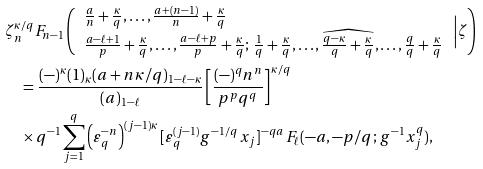<formula> <loc_0><loc_0><loc_500><loc_500>& \zeta ^ { \kappa / q } _ { n } F _ { n - 1 } \left ( \begin{array} { l } \frac { a } n + \frac { \kappa } q , \dots , \frac { a + ( n - 1 ) } n + \frac { \kappa } q \\ \frac { a - \ell + 1 } p + \frac { \kappa } q , \dots , \frac { a - \ell + p } p + \frac { \kappa } q ; \, \frac { 1 } { q } + \frac { \kappa } q , \dots , \widehat { \frac { q - \kappa } q + \frac { \kappa } q } , \dots , \frac { q } q + \frac { \kappa } q \end{array} \, \Big | \zeta \right ) \\ & \quad = \frac { ( - ) ^ { \kappa } ( 1 ) _ { \kappa } ( a + n \kappa / q ) _ { 1 - \ell - \kappa } } { ( a ) _ { 1 - \ell } } \left [ \frac { ( - ) ^ { q } n ^ { n } } { p ^ { p } q ^ { q } } \right ] ^ { \kappa / q } \\ & \quad \times q ^ { - 1 } \sum _ { j = 1 } ^ { q } \left ( \varepsilon _ { q } ^ { - n } \right ) ^ { ( j - 1 ) \kappa } [ \varepsilon _ { q } ^ { ( j - 1 ) } g ^ { - 1 / q } \, x _ { j } ] ^ { - q a } \, F _ { \ell } ( - a , - p / q ; \, g ^ { - 1 } x _ { j } ^ { q } ) ,</formula> 